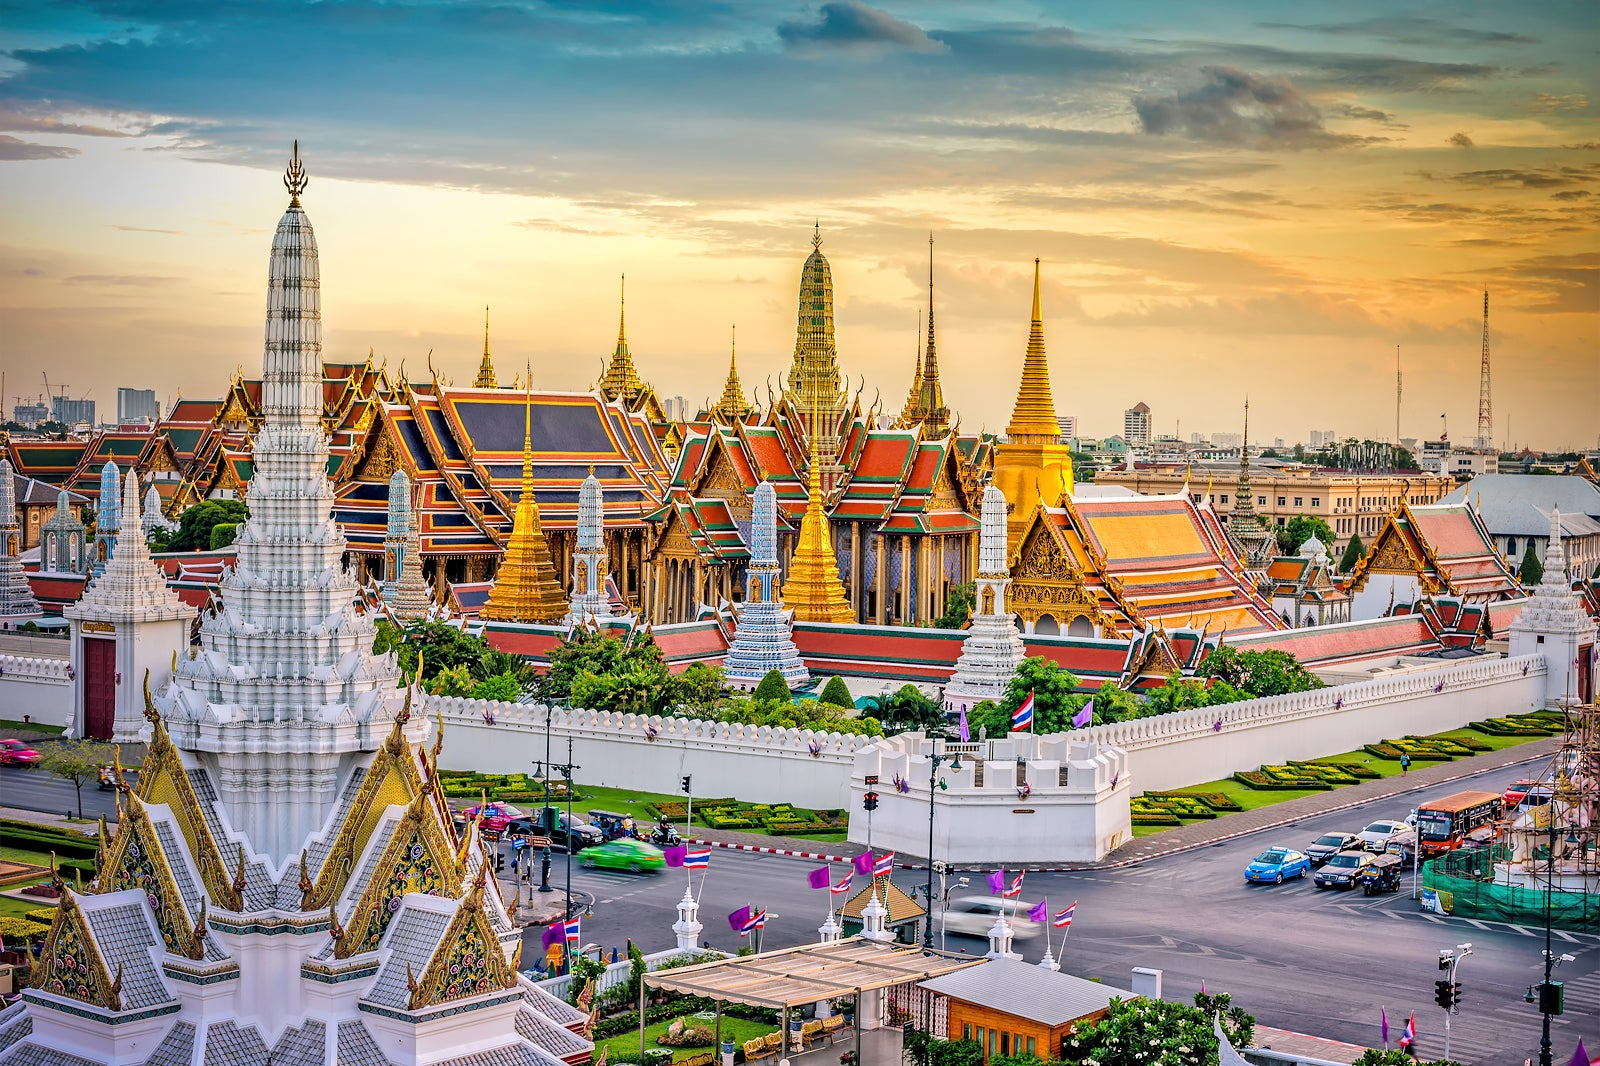What are some nearby attractions one could visit after seeing the Grand Palace? After visiting the Grand Palace, there are several nearby attractions in Bangkok that are definitely worth exploring. One could visit Wat Pho, home to the famous Reclining Buddha, just a short walk away. Nearby is Wat Arun, the Temple of Dawn, which offers stunning river views. The vibrant Tha Tien Market is perfect for sharegpt4v/sampling local Thai delicacies. For art enthusiasts, the Bangkok National Museum provides a deep dive into Thailand’s history and culture. Finally, a leisurely boat ride on the Chao Phraya River offers a relaxing way to see Bangkok’s riverside landmarks. 